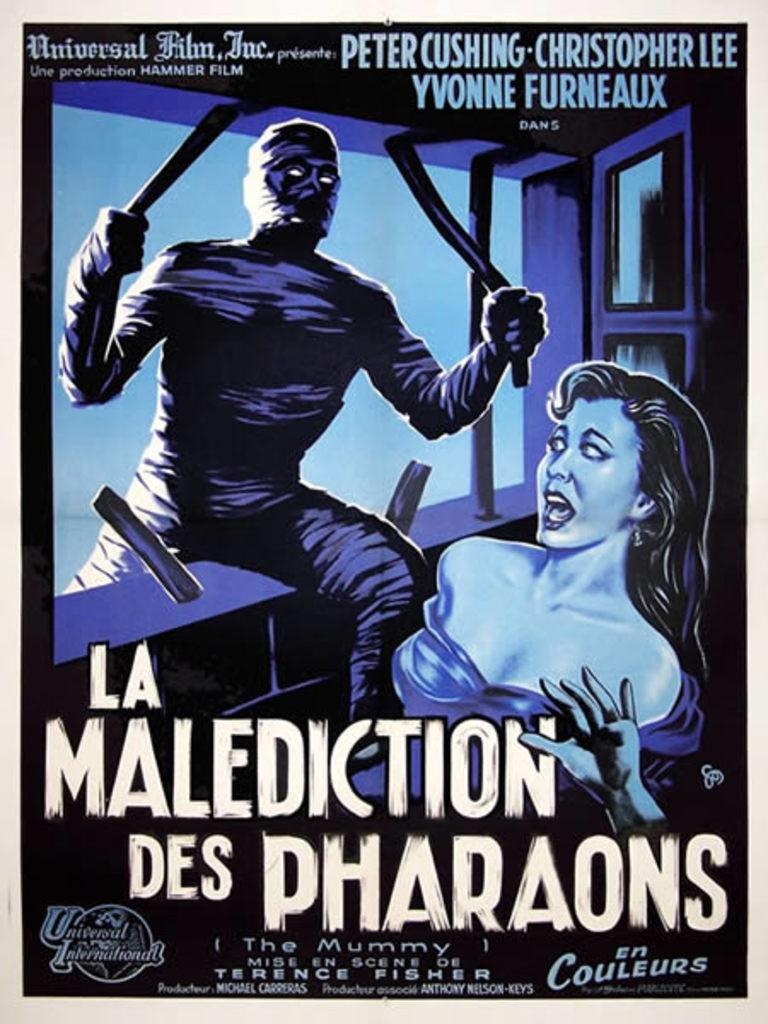<image>
Offer a succinct explanation of the picture presented. an old movie poster of a peter cushing movie 